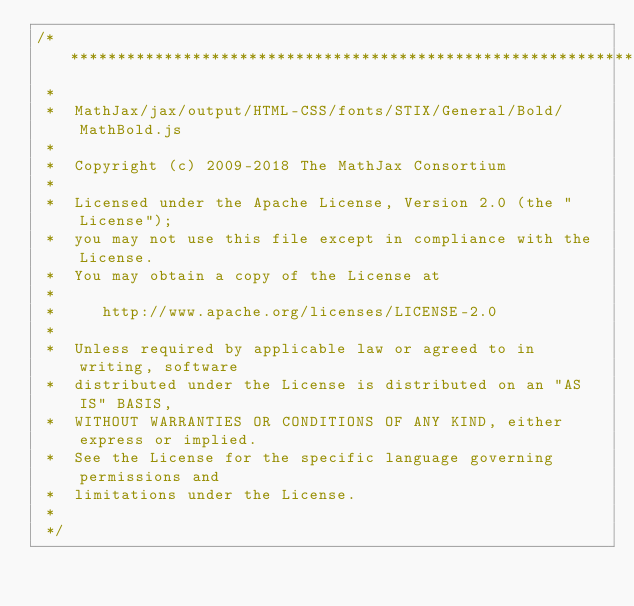Convert code to text. <code><loc_0><loc_0><loc_500><loc_500><_JavaScript_>/*************************************************************
 *
 *  MathJax/jax/output/HTML-CSS/fonts/STIX/General/Bold/MathBold.js
 *
 *  Copyright (c) 2009-2018 The MathJax Consortium
 *
 *  Licensed under the Apache License, Version 2.0 (the "License");
 *  you may not use this file except in compliance with the License.
 *  You may obtain a copy of the License at
 *
 *     http://www.apache.org/licenses/LICENSE-2.0
 *
 *  Unless required by applicable law or agreed to in writing, software
 *  distributed under the License is distributed on an "AS IS" BASIS,
 *  WITHOUT WARRANTIES OR CONDITIONS OF ANY KIND, either express or implied.
 *  See the License for the specific language governing permissions and
 *  limitations under the License.
 *
 */
</code> 